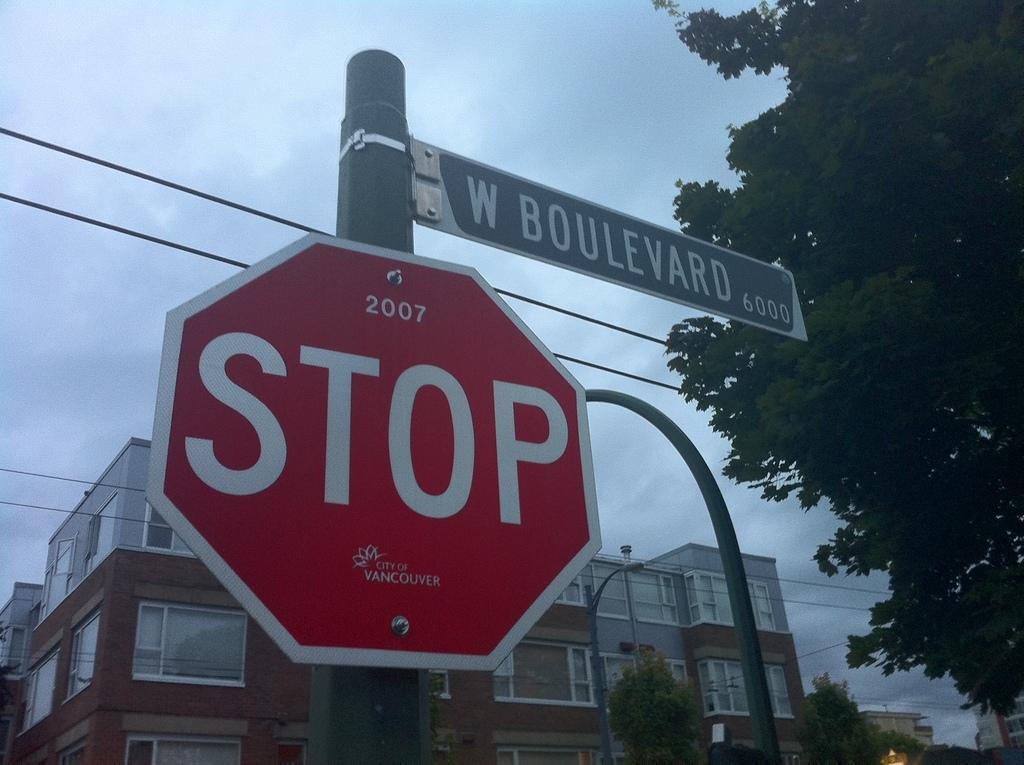Provide a one-sentence caption for the provided image. A red stop sign on a post with a street sign of W, Boulevard also attached to the post. 